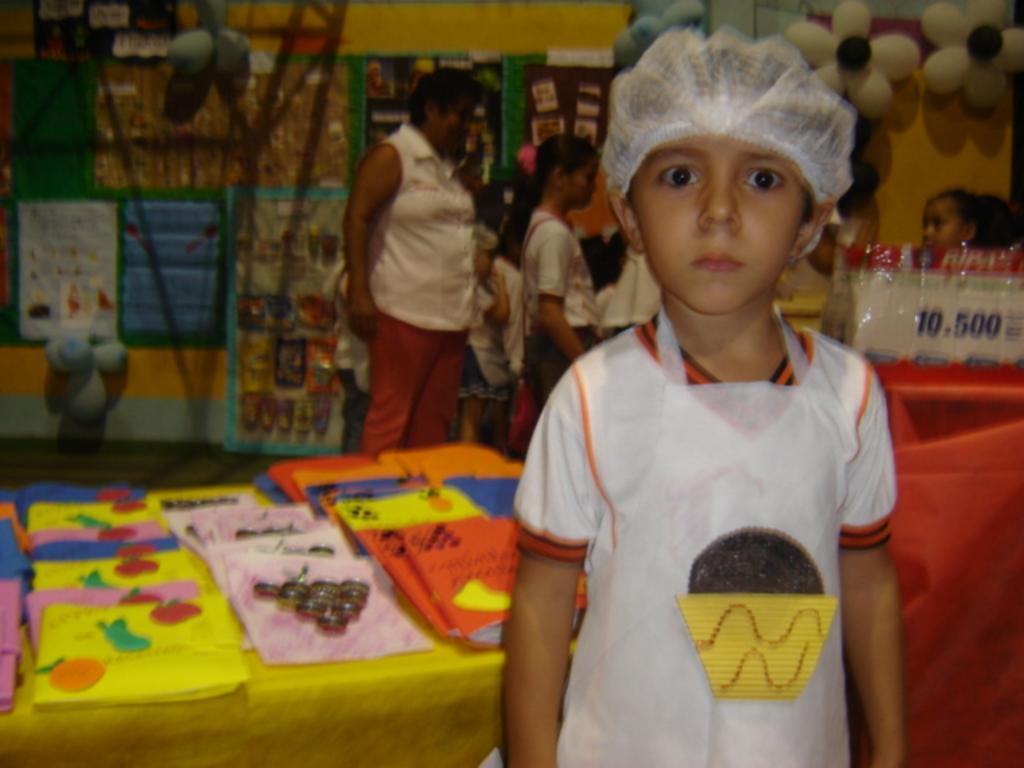Could you give a brief overview of what you see in this image? In the foreground of the picture there are books, table, card, a kid and various objects. In the background there are people, posters, balloons, wall and other things. 